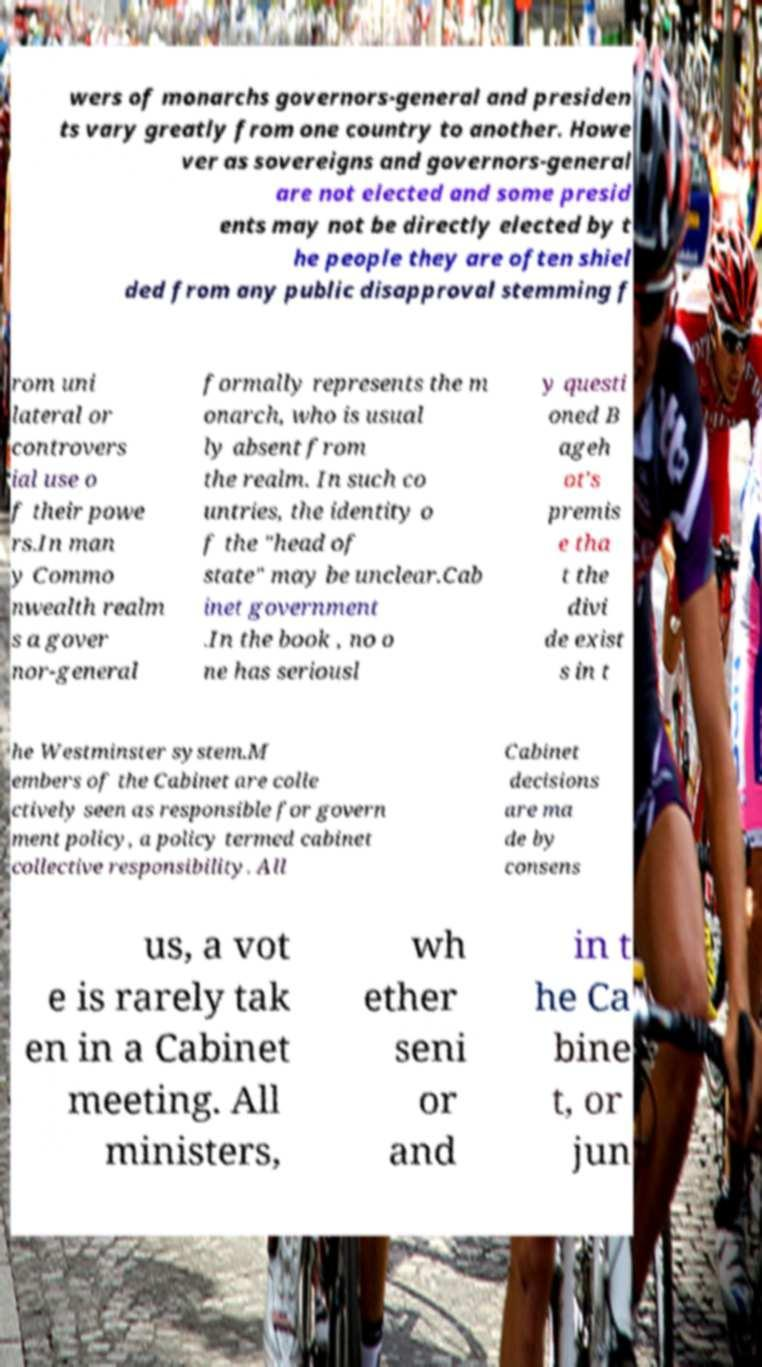Please identify and transcribe the text found in this image. wers of monarchs governors-general and presiden ts vary greatly from one country to another. Howe ver as sovereigns and governors-general are not elected and some presid ents may not be directly elected by t he people they are often shiel ded from any public disapproval stemming f rom uni lateral or controvers ial use o f their powe rs.In man y Commo nwealth realm s a gover nor-general formally represents the m onarch, who is usual ly absent from the realm. In such co untries, the identity o f the "head of state" may be unclear.Cab inet government .In the book , no o ne has seriousl y questi oned B ageh ot's premis e tha t the divi de exist s in t he Westminster system.M embers of the Cabinet are colle ctively seen as responsible for govern ment policy, a policy termed cabinet collective responsibility. All Cabinet decisions are ma de by consens us, a vot e is rarely tak en in a Cabinet meeting. All ministers, wh ether seni or and in t he Ca bine t, or jun 